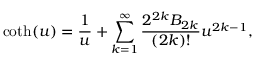Convert formula to latex. <formula><loc_0><loc_0><loc_500><loc_500>\coth ( u ) = \frac { 1 } { u } + \sum _ { k = 1 } ^ { \infty } \frac { 2 ^ { 2 k } B _ { 2 k } } { ( 2 k ) ! } u ^ { 2 k - 1 } ,</formula> 